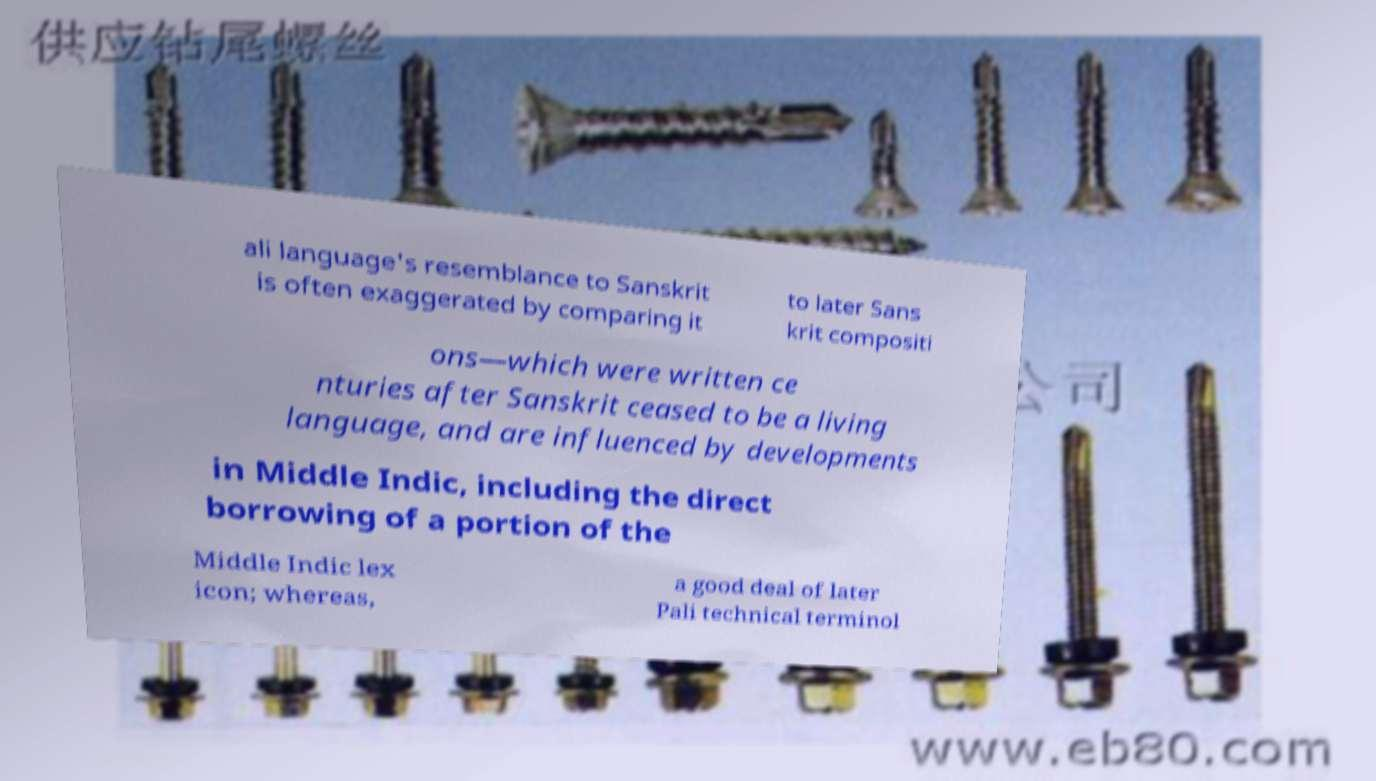Please identify and transcribe the text found in this image. ali language's resemblance to Sanskrit is often exaggerated by comparing it to later Sans krit compositi ons—which were written ce nturies after Sanskrit ceased to be a living language, and are influenced by developments in Middle Indic, including the direct borrowing of a portion of the Middle Indic lex icon; whereas, a good deal of later Pali technical terminol 